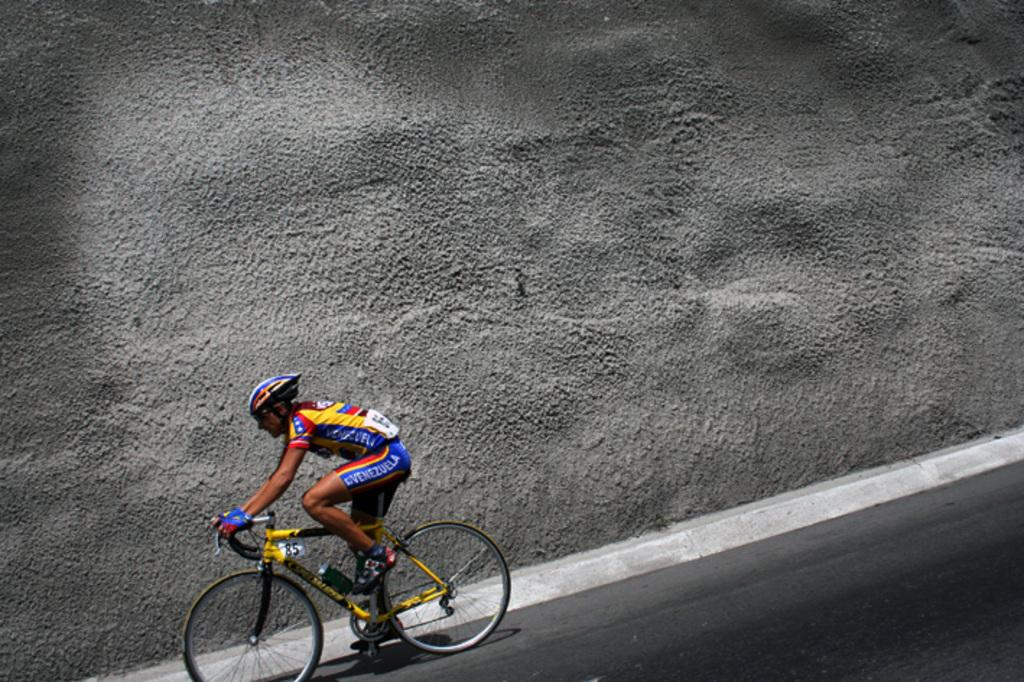Who is the main subject in the image? There is a man in the image. What is the man doing in the image? The man is sitting and riding a bicycle on the road. What safety equipment is the man wearing? The man is wearing a helmet and gloves. What can be seen in the background of the image? There is a wall visible in the background of the image. What type of answer is the man providing to the manager in the image? There is no manager or conversation present in the image; it only shows a man riding a bicycle. Is the image taken during the night? The image does not provide any information about the time of day, so it cannot be determined if it was taken during the night. 